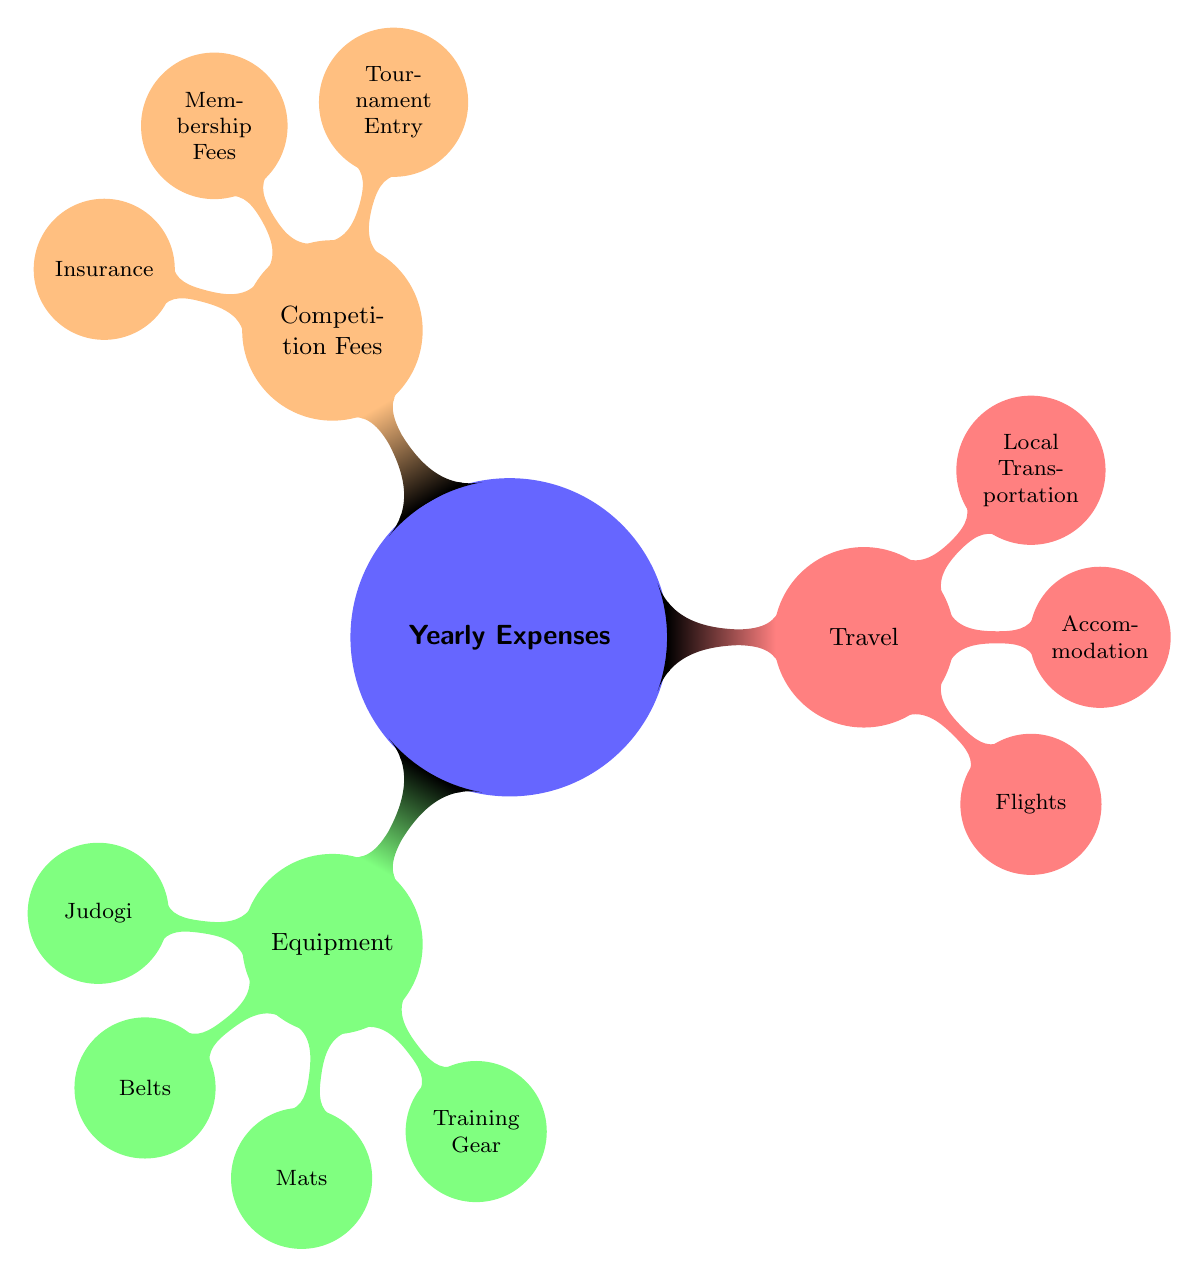What are the three main categories of yearly expenses? The diagram displays three main categories of expenses which are Equipment, Travel, and Competition Fees.
Answer: Equipment, Travel, Competition Fees How many items are listed under the Equipment category? The Equipment category has four items listed: Judogi, Belts, Mats, and Training Gear. Counting these, there are a total of four items.
Answer: 4 What is the color associated with the Travel category? The diagram uses red as the color to represent the Travel category. This is identified by the node's color in the diagram.
Answer: Red Which item falls under the Competition Fees category that relates to entry costs? The diagram lists Tournament Entry as an item under the Competition Fees category which directly relates to costs for entering competitions.
Answer: Tournament Entry Which category includes accommodation-related expenses? The Travel category includes accommodation-related expenses as indicated by the item Accommodation under that category.
Answer: Travel How many items are under the Travel category? Within the Travel category, there are three listed items: Flights, Accommodation, and Local Transportation. Therefore, there are a total of three items.
Answer: 3 If you add the number of items from Equipment and Competition Fees, how many items will that be? The Equipment category has four items and the Competition Fees category has three items. Adding them together, 4 + 3 results in 7 items total.
Answer: 7 What are the items listed under the Equipment category in order? The Equipment category in the diagram lists the following items in order: Judogi, Belts, Mats, and Training Gear. This can be confirmed by tracing the branches under the Equipment node.
Answer: Judogi, Belts, Mats, Training Gear Which expense items might contribute to travel costs? The items contributing to travel costs include Flights, Accommodation, and Local Transportation, all of which fall under the Travel category in the diagram.
Answer: Flights, Accommodation, Local Transportation 